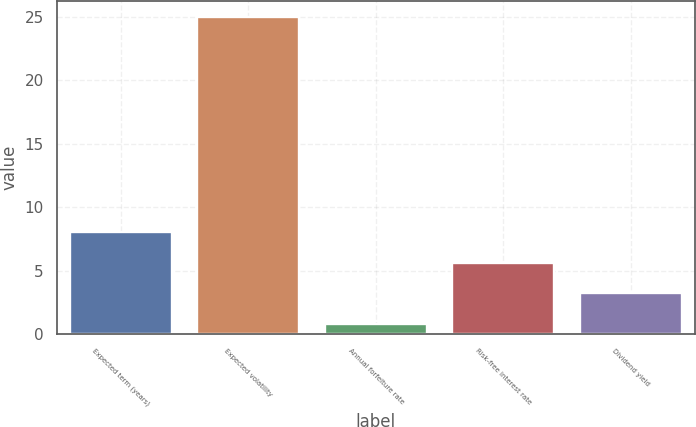Convert chart. <chart><loc_0><loc_0><loc_500><loc_500><bar_chart><fcel>Expected term (years)<fcel>Expected volatility<fcel>Annual forfeiture rate<fcel>Risk-free interest rate<fcel>Dividend yield<nl><fcel>8.06<fcel>25<fcel>0.8<fcel>5.64<fcel>3.22<nl></chart> 